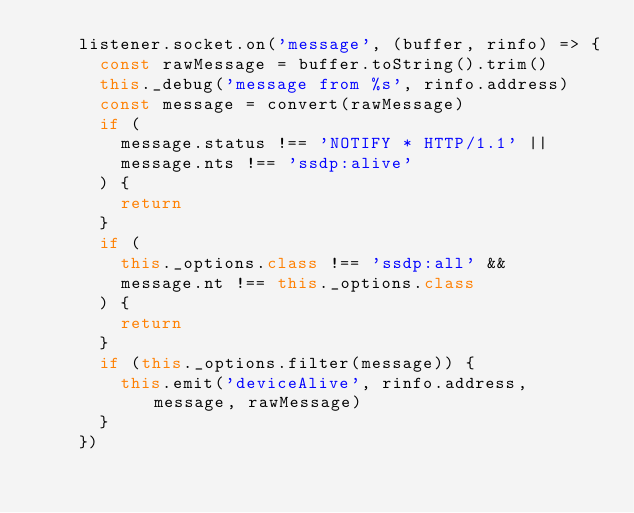Convert code to text. <code><loc_0><loc_0><loc_500><loc_500><_JavaScript_>    listener.socket.on('message', (buffer, rinfo) => {
      const rawMessage = buffer.toString().trim()
      this._debug('message from %s', rinfo.address)
      const message = convert(rawMessage)
      if (
        message.status !== 'NOTIFY * HTTP/1.1' ||
        message.nts !== 'ssdp:alive'
      ) {
        return
      }
      if (
        this._options.class !== 'ssdp:all' &&
        message.nt !== this._options.class
      ) {
        return
      }
      if (this._options.filter(message)) {
        this.emit('deviceAlive', rinfo.address, message, rawMessage)
      }
    })
</code> 